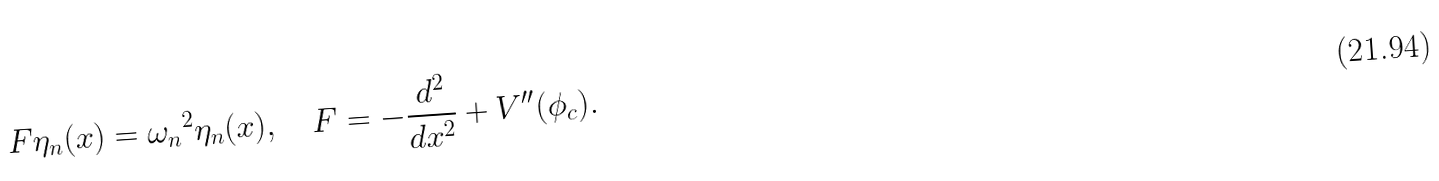<formula> <loc_0><loc_0><loc_500><loc_500>F \eta _ { n } ( x ) = \omega _ { n } { ^ { 2 } } \eta _ { n } ( x ) , \quad F = - \frac { d ^ { 2 } } { d x ^ { 2 } } + V ^ { \prime \prime } ( \phi _ { c } ) .</formula> 